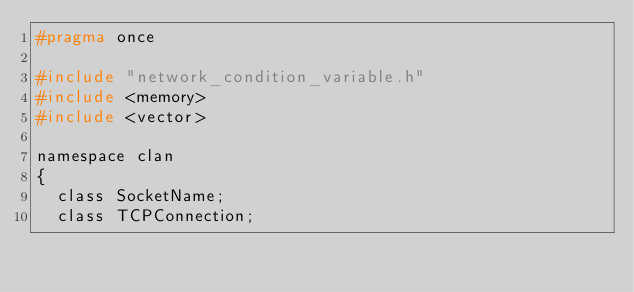<code> <loc_0><loc_0><loc_500><loc_500><_C_>#pragma once

#include "network_condition_variable.h"
#include <memory>
#include <vector>

namespace clan
{
	class SocketName;
	class TCPConnection;</code> 